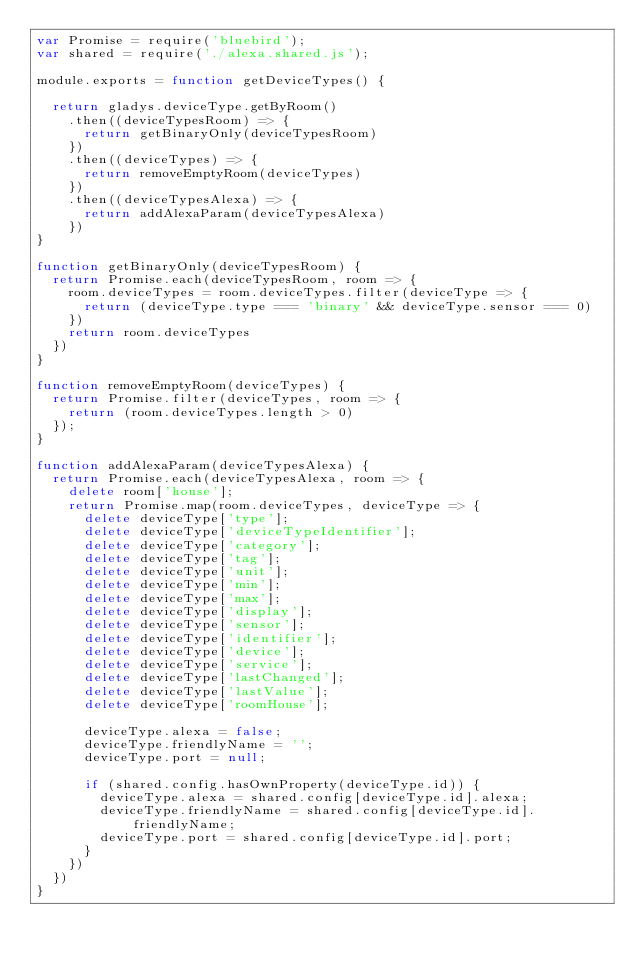<code> <loc_0><loc_0><loc_500><loc_500><_JavaScript_>var Promise = require('bluebird');
var shared = require('./alexa.shared.js');

module.exports = function getDeviceTypes() {

  return gladys.deviceType.getByRoom()
    .then((deviceTypesRoom) => {
      return getBinaryOnly(deviceTypesRoom)
    })
    .then((deviceTypes) => {
      return removeEmptyRoom(deviceTypes)
    })
    .then((deviceTypesAlexa) => {
      return addAlexaParam(deviceTypesAlexa)
    })
}

function getBinaryOnly(deviceTypesRoom) {
  return Promise.each(deviceTypesRoom, room => {
    room.deviceTypes = room.deviceTypes.filter(deviceType => {
      return (deviceType.type === 'binary' && deviceType.sensor === 0)
    })
    return room.deviceTypes
  })
}

function removeEmptyRoom(deviceTypes) {
  return Promise.filter(deviceTypes, room => {
    return (room.deviceTypes.length > 0)
  });
}

function addAlexaParam(deviceTypesAlexa) {
  return Promise.each(deviceTypesAlexa, room => {
    delete room['house'];
    return Promise.map(room.deviceTypes, deviceType => {
      delete deviceType['type'];
      delete deviceType['deviceTypeIdentifier'];
      delete deviceType['category'];
      delete deviceType['tag'];
      delete deviceType['unit'];
      delete deviceType['min'];
      delete deviceType['max'];
      delete deviceType['display'];
      delete deviceType['sensor'];
      delete deviceType['identifier'];
      delete deviceType['device'];
      delete deviceType['service'];
      delete deviceType['lastChanged'];
      delete deviceType['lastValue'];
      delete deviceType['roomHouse'];

      deviceType.alexa = false;
      deviceType.friendlyName = '';
      deviceType.port = null;

      if (shared.config.hasOwnProperty(deviceType.id)) {
        deviceType.alexa = shared.config[deviceType.id].alexa;
        deviceType.friendlyName = shared.config[deviceType.id].friendlyName;
        deviceType.port = shared.config[deviceType.id].port;
      }
    })
  })
}</code> 